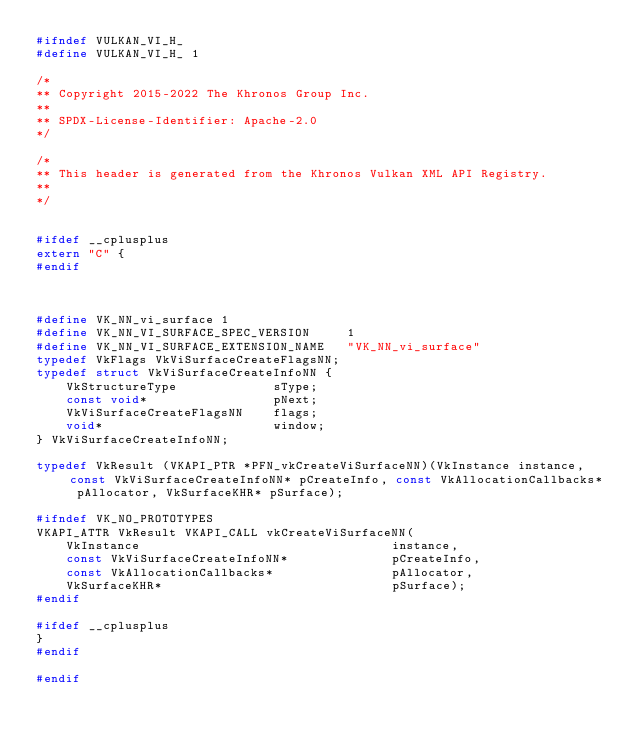<code> <loc_0><loc_0><loc_500><loc_500><_C_>#ifndef VULKAN_VI_H_
#define VULKAN_VI_H_ 1

/*
** Copyright 2015-2022 The Khronos Group Inc.
**
** SPDX-License-Identifier: Apache-2.0
*/

/*
** This header is generated from the Khronos Vulkan XML API Registry.
**
*/


#ifdef __cplusplus
extern "C" {
#endif



#define VK_NN_vi_surface 1
#define VK_NN_VI_SURFACE_SPEC_VERSION     1
#define VK_NN_VI_SURFACE_EXTENSION_NAME   "VK_NN_vi_surface"
typedef VkFlags VkViSurfaceCreateFlagsNN;
typedef struct VkViSurfaceCreateInfoNN {
    VkStructureType             sType;
    const void*                 pNext;
    VkViSurfaceCreateFlagsNN    flags;
    void*                       window;
} VkViSurfaceCreateInfoNN;

typedef VkResult (VKAPI_PTR *PFN_vkCreateViSurfaceNN)(VkInstance instance, const VkViSurfaceCreateInfoNN* pCreateInfo, const VkAllocationCallbacks* pAllocator, VkSurfaceKHR* pSurface);

#ifndef VK_NO_PROTOTYPES
VKAPI_ATTR VkResult VKAPI_CALL vkCreateViSurfaceNN(
    VkInstance                                  instance,
    const VkViSurfaceCreateInfoNN*              pCreateInfo,
    const VkAllocationCallbacks*                pAllocator,
    VkSurfaceKHR*                               pSurface);
#endif

#ifdef __cplusplus
}
#endif

#endif
</code> 